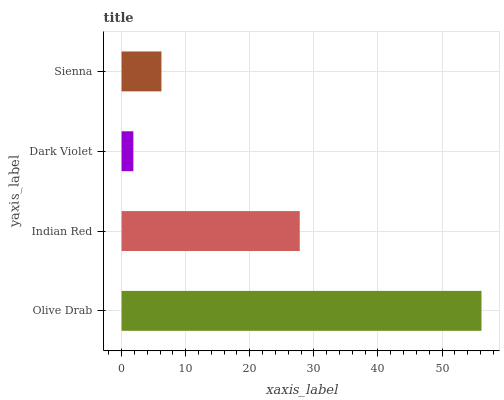Is Dark Violet the minimum?
Answer yes or no. Yes. Is Olive Drab the maximum?
Answer yes or no. Yes. Is Indian Red the minimum?
Answer yes or no. No. Is Indian Red the maximum?
Answer yes or no. No. Is Olive Drab greater than Indian Red?
Answer yes or no. Yes. Is Indian Red less than Olive Drab?
Answer yes or no. Yes. Is Indian Red greater than Olive Drab?
Answer yes or no. No. Is Olive Drab less than Indian Red?
Answer yes or no. No. Is Indian Red the high median?
Answer yes or no. Yes. Is Sienna the low median?
Answer yes or no. Yes. Is Sienna the high median?
Answer yes or no. No. Is Dark Violet the low median?
Answer yes or no. No. 